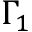<formula> <loc_0><loc_0><loc_500><loc_500>\Gamma _ { 1 }</formula> 